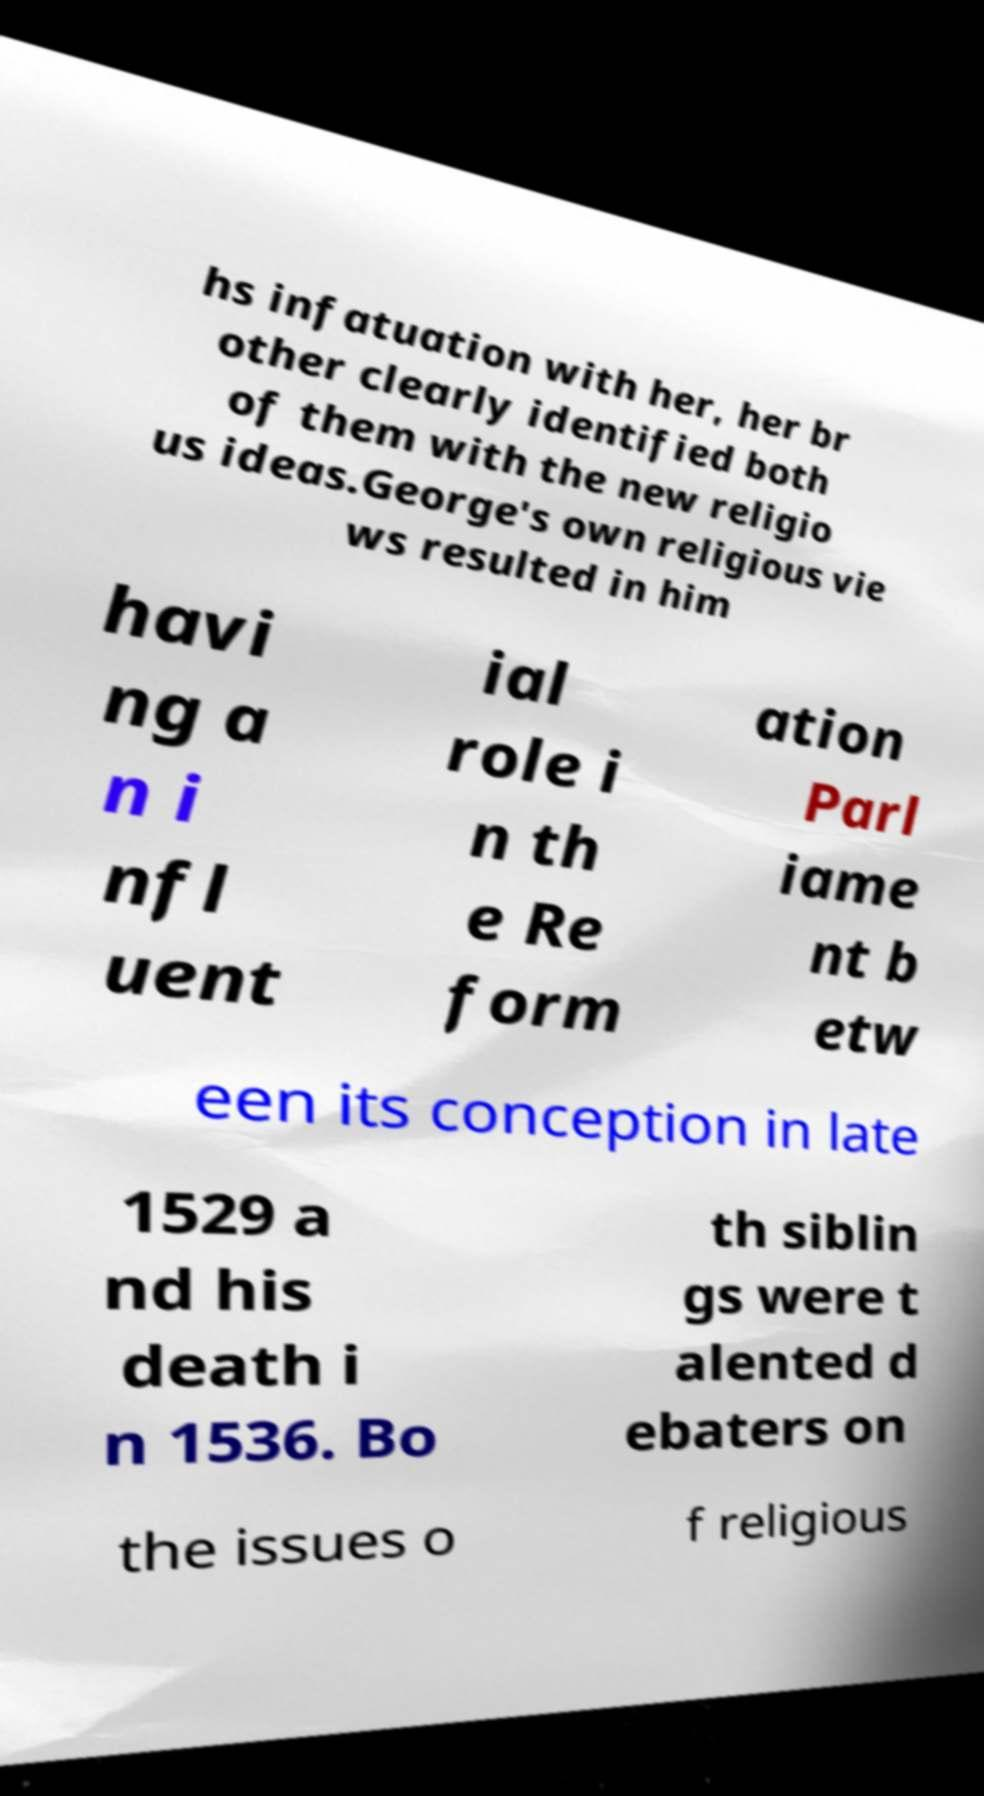Could you assist in decoding the text presented in this image and type it out clearly? hs infatuation with her, her br other clearly identified both of them with the new religio us ideas.George's own religious vie ws resulted in him havi ng a n i nfl uent ial role i n th e Re form ation Parl iame nt b etw een its conception in late 1529 a nd his death i n 1536. Bo th siblin gs were t alented d ebaters on the issues o f religious 